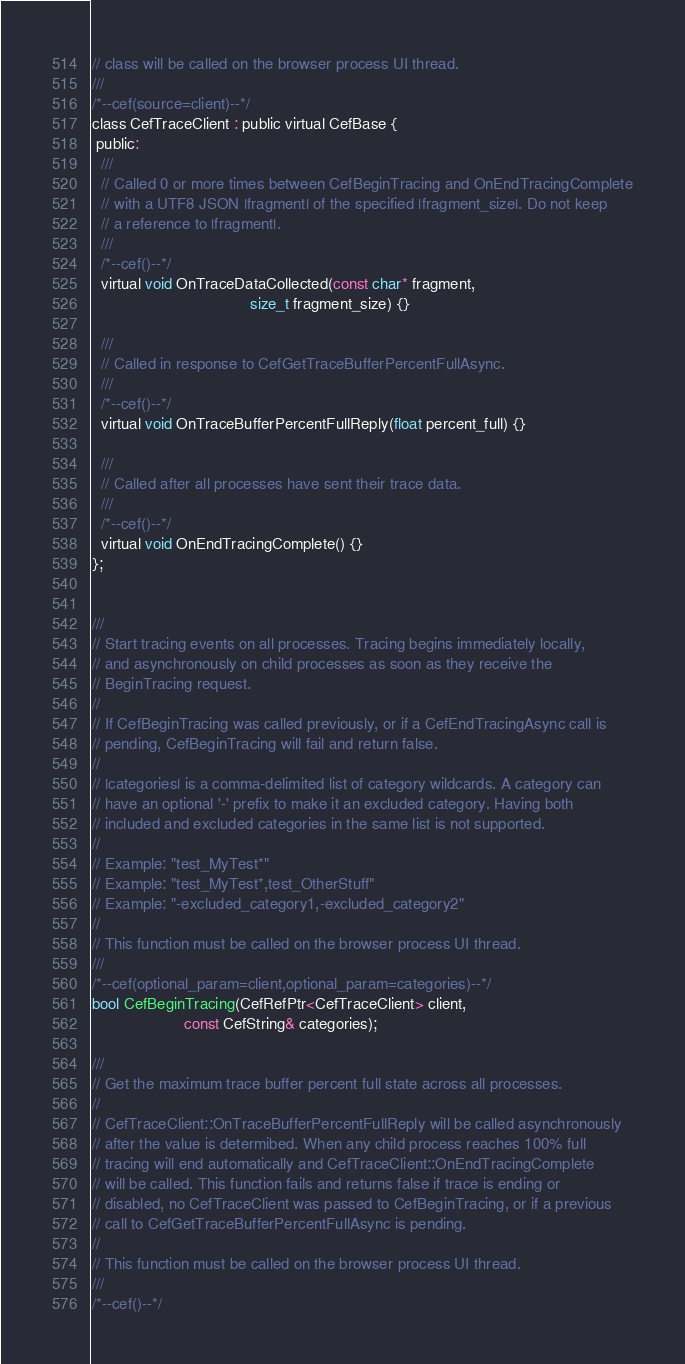<code> <loc_0><loc_0><loc_500><loc_500><_C_>// class will be called on the browser process UI thread.
///
/*--cef(source=client)--*/
class CefTraceClient : public virtual CefBase {
 public:
  ///
  // Called 0 or more times between CefBeginTracing and OnEndTracingComplete
  // with a UTF8 JSON |fragment| of the specified |fragment_size|. Do not keep
  // a reference to |fragment|.
  ///
  /*--cef()--*/
  virtual void OnTraceDataCollected(const char* fragment,
                                    size_t fragment_size) {}

  ///
  // Called in response to CefGetTraceBufferPercentFullAsync.
  ///
  /*--cef()--*/
  virtual void OnTraceBufferPercentFullReply(float percent_full) {}

  ///
  // Called after all processes have sent their trace data.
  ///
  /*--cef()--*/
  virtual void OnEndTracingComplete() {}
};


///
// Start tracing events on all processes. Tracing begins immediately locally,
// and asynchronously on child processes as soon as they receive the
// BeginTracing request.
//
// If CefBeginTracing was called previously, or if a CefEndTracingAsync call is
// pending, CefBeginTracing will fail and return false.
//
// |categories| is a comma-delimited list of category wildcards. A category can
// have an optional '-' prefix to make it an excluded category. Having both
// included and excluded categories in the same list is not supported.
//
// Example: "test_MyTest*"
// Example: "test_MyTest*,test_OtherStuff"
// Example: "-excluded_category1,-excluded_category2"
//
// This function must be called on the browser process UI thread.
///
/*--cef(optional_param=client,optional_param=categories)--*/
bool CefBeginTracing(CefRefPtr<CefTraceClient> client,
                     const CefString& categories);

///
// Get the maximum trace buffer percent full state across all processes.
//
// CefTraceClient::OnTraceBufferPercentFullReply will be called asynchronously
// after the value is determibed. When any child process reaches 100% full
// tracing will end automatically and CefTraceClient::OnEndTracingComplete
// will be called. This function fails and returns false if trace is ending or
// disabled, no CefTraceClient was passed to CefBeginTracing, or if a previous
// call to CefGetTraceBufferPercentFullAsync is pending.
//
// This function must be called on the browser process UI thread.
///
/*--cef()--*/</code> 